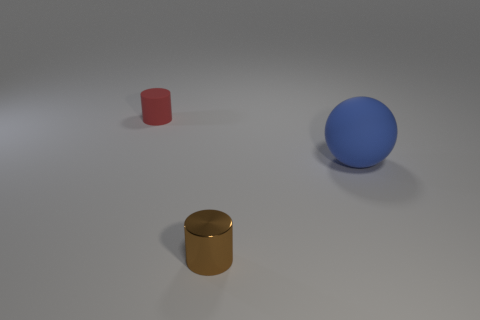Add 1 large blue things. How many objects exist? 4 Subtract all cylinders. How many objects are left? 1 Subtract all large gray balls. Subtract all spheres. How many objects are left? 2 Add 1 red rubber things. How many red rubber things are left? 2 Add 2 small yellow metallic blocks. How many small yellow metallic blocks exist? 2 Subtract 0 yellow spheres. How many objects are left? 3 